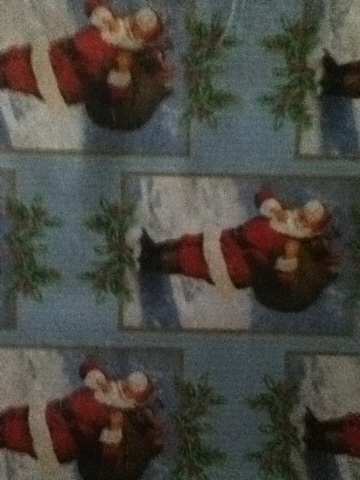If you received a gift wrapped in this paper, what might you expect to find inside? If I received a gift wrapped in this Christmas-themed paper, I might expect to find something festive or seasonally appropriate inside. This could be anything from a holiday-themed ornament, a piece of winter clothing, a toy, or even holiday treats like chocolates or cookies. 